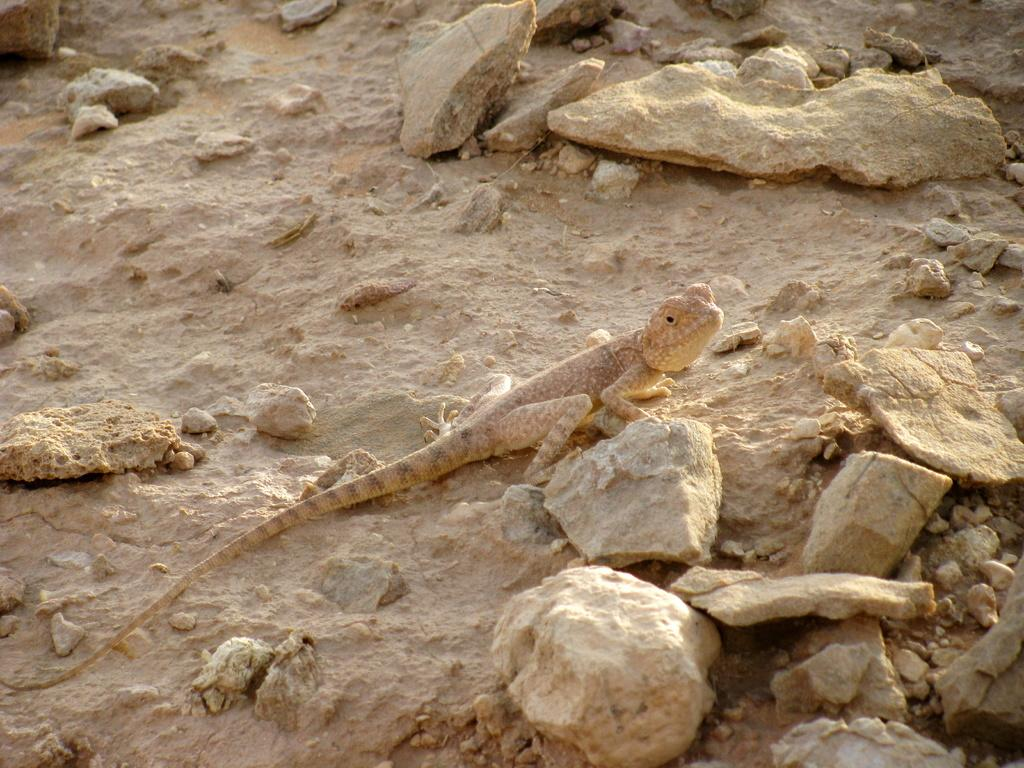What type of animal is present on the surface in the image? There is a lizard on the surface in the image. What else can be seen on the surface in the image? There are stones visible in the image. How many icicles are hanging from the lizard in the image? There are no icicles present in the image; it features a lizard on a surface with stones. What type of plastic object can be seen in the image? There is no plastic object present in the image. 